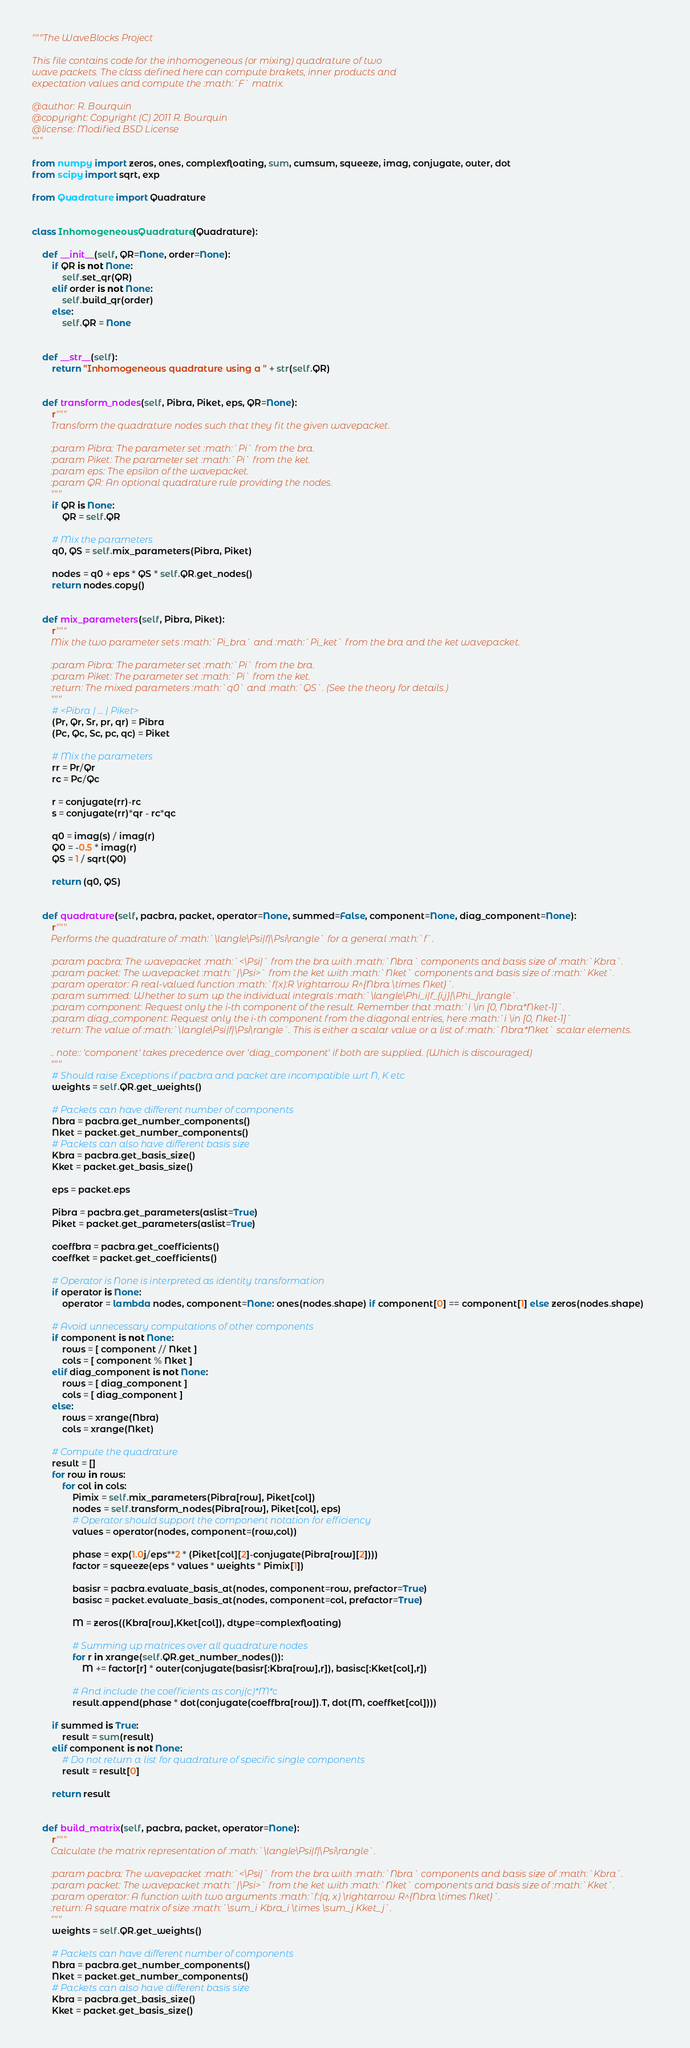<code> <loc_0><loc_0><loc_500><loc_500><_Python_>"""The WaveBlocks Project

This file contains code for the inhomogeneous (or mixing) quadrature of two
wave packets. The class defined here can compute brakets, inner products and
expectation values and compute the :math:`F` matrix.

@author: R. Bourquin
@copyright: Copyright (C) 2011 R. Bourquin
@license: Modified BSD License
"""

from numpy import zeros, ones, complexfloating, sum, cumsum, squeeze, imag, conjugate, outer, dot
from scipy import sqrt, exp

from Quadrature import Quadrature


class InhomogeneousQuadrature(Quadrature):

    def __init__(self, QR=None, order=None):
        if QR is not None:
            self.set_qr(QR)
        elif order is not None:
            self.build_qr(order)
        else:
            self.QR = None


    def __str__(self):
        return "Inhomogeneous quadrature using a " + str(self.QR)


    def transform_nodes(self, Pibra, Piket, eps, QR=None):
        r"""
        Transform the quadrature nodes such that they fit the given wavepacket.

        :param Pibra: The parameter set :math:`Pi` from the bra.
        :param Piket: The parameter set :math:`Pi` from the ket.
        :param eps: The epsilon of the wavepacket.
        :param QR: An optional quadrature rule providing the nodes.
        """
        if QR is None:
            QR = self.QR

        # Mix the parameters
        q0, QS = self.mix_parameters(Pibra, Piket)

        nodes = q0 + eps * QS * self.QR.get_nodes()
        return nodes.copy()


    def mix_parameters(self, Pibra, Piket):
        r"""
        Mix the two parameter sets :math:`Pi_bra` and :math:`Pi_ket` from the bra and the ket wavepacket.

        :param Pibra: The parameter set :math:`Pi` from the bra.
        :param Piket: The parameter set :math:`Pi` from the ket.
        :return: The mixed parameters :math:`q0` and :math:`QS`. (See the theory for details.)
        """
        # <Pibra | ... | Piket>
        (Pr, Qr, Sr, pr, qr) = Pibra
        (Pc, Qc, Sc, pc, qc) = Piket

        # Mix the parameters
        rr = Pr/Qr
        rc = Pc/Qc

        r = conjugate(rr)-rc
        s = conjugate(rr)*qr - rc*qc

        q0 = imag(s) / imag(r)
        Q0 = -0.5 * imag(r)
        QS = 1 / sqrt(Q0)

        return (q0, QS)


    def quadrature(self, pacbra, packet, operator=None, summed=False, component=None, diag_component=None):
        r"""
        Performs the quadrature of :math:`\langle\Psi|f|\Psi\rangle` for a general :math:`f`.

        :param pacbra: The wavepacket :math:`<\Psi|` from the bra with :math:`Nbra` components and basis size of :math:`Kbra`.
        :param packet: The wavepacket :math:`|\Psi>` from the ket with :math:`Nket` components and basis size of :math:`Kket`.
        :param operator: A real-valued function :math:`f(x):R \rightarrow R^{Nbra \times Nket}`.
        :param summed: Whether to sum up the individual integrals :math:`\langle\Phi_i|f_{i,j}|\Phi_j\rangle`.
        :param component: Request only the i-th component of the result. Remember that :math:`i \in [0, Nbra*Nket-1]`.
        :param diag_component: Request only the i-th component from the diagonal entries, here :math:`i \in [0, Nket-1]`
        :return: The value of :math:`\langle\Psi|f|\Psi\rangle`. This is either a scalar value or a list of :math:`Nbra*Nket` scalar elements.

        .. note:: 'component' takes precedence over 'diag_component' if both are supplied. (Which is discouraged)
        """
        # Should raise Exceptions if pacbra and packet are incompatible wrt N, K etc
        weights = self.QR.get_weights()

        # Packets can have different number of components
        Nbra = pacbra.get_number_components()
        Nket = packet.get_number_components()
        # Packets can also have different basis size
        Kbra = pacbra.get_basis_size()
        Kket = packet.get_basis_size()

        eps = packet.eps

        Pibra = pacbra.get_parameters(aslist=True)
        Piket = packet.get_parameters(aslist=True)

        coeffbra = pacbra.get_coefficients()
        coeffket = packet.get_coefficients()

        # Operator is None is interpreted as identity transformation
        if operator is None:
            operator = lambda nodes, component=None: ones(nodes.shape) if component[0] == component[1] else zeros(nodes.shape)

        # Avoid unnecessary computations of other components
        if component is not None:
            rows = [ component // Nket ]
            cols = [ component % Nket ]
        elif diag_component is not None:
            rows = [ diag_component ]
            cols = [ diag_component ]
        else:
            rows = xrange(Nbra)
            cols = xrange(Nket)

        # Compute the quadrature
        result = []
        for row in rows:
            for col in cols:
                Pimix = self.mix_parameters(Pibra[row], Piket[col])
                nodes = self.transform_nodes(Pibra[row], Piket[col], eps)
                # Operator should support the component notation for efficiency
                values = operator(nodes, component=(row,col))

                phase = exp(1.0j/eps**2 * (Piket[col][2]-conjugate(Pibra[row][2])))
                factor = squeeze(eps * values * weights * Pimix[1])

                basisr = pacbra.evaluate_basis_at(nodes, component=row, prefactor=True)
                basisc = packet.evaluate_basis_at(nodes, component=col, prefactor=True)

                M = zeros((Kbra[row],Kket[col]), dtype=complexfloating)

                # Summing up matrices over all quadrature nodes
                for r in xrange(self.QR.get_number_nodes()):
                    M += factor[r] * outer(conjugate(basisr[:Kbra[row],r]), basisc[:Kket[col],r])

                # And include the coefficients as conj(c)*M*c
                result.append(phase * dot(conjugate(coeffbra[row]).T, dot(M, coeffket[col])))

        if summed is True:
            result = sum(result)
        elif component is not None:
            # Do not return a list for quadrature of specific single components
            result = result[0]

        return result


    def build_matrix(self, pacbra, packet, operator=None):
        r"""
        Calculate the matrix representation of :math:`\langle\Psi|f|\Psi\rangle`.

        :param pacbra: The wavepacket :math:`<\Psi|` from the bra with :math:`Nbra` components and basis size of :math:`Kbra`.
        :param packet: The wavepacket :math:`|\Psi>` from the ket with :math:`Nket` components and basis size of :math:`Kket`.
        :param operator: A function with two arguments :math:`f:(q, x) \rightarrow R^{Nbra \times Nket}`.
        :return: A square matrix of size :math:`\sum_i Kbra_i \times \sum_j Kket_j`.
        """
        weights = self.QR.get_weights()

        # Packets can have different number of components
        Nbra = pacbra.get_number_components()
        Nket = packet.get_number_components()
        # Packets can also have different basis size
        Kbra = pacbra.get_basis_size()
        Kket = packet.get_basis_size()</code> 